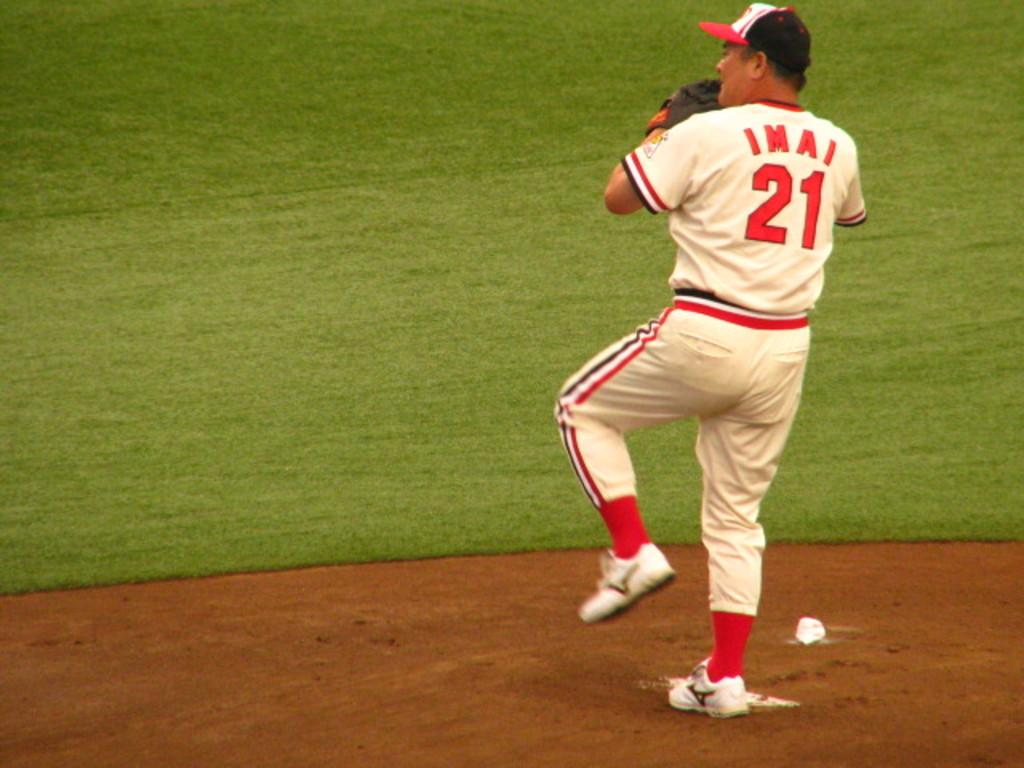Provide a one-sentence caption for the provided image. Imai, number 21, prepares to pitch the ball in a game of baseball. 